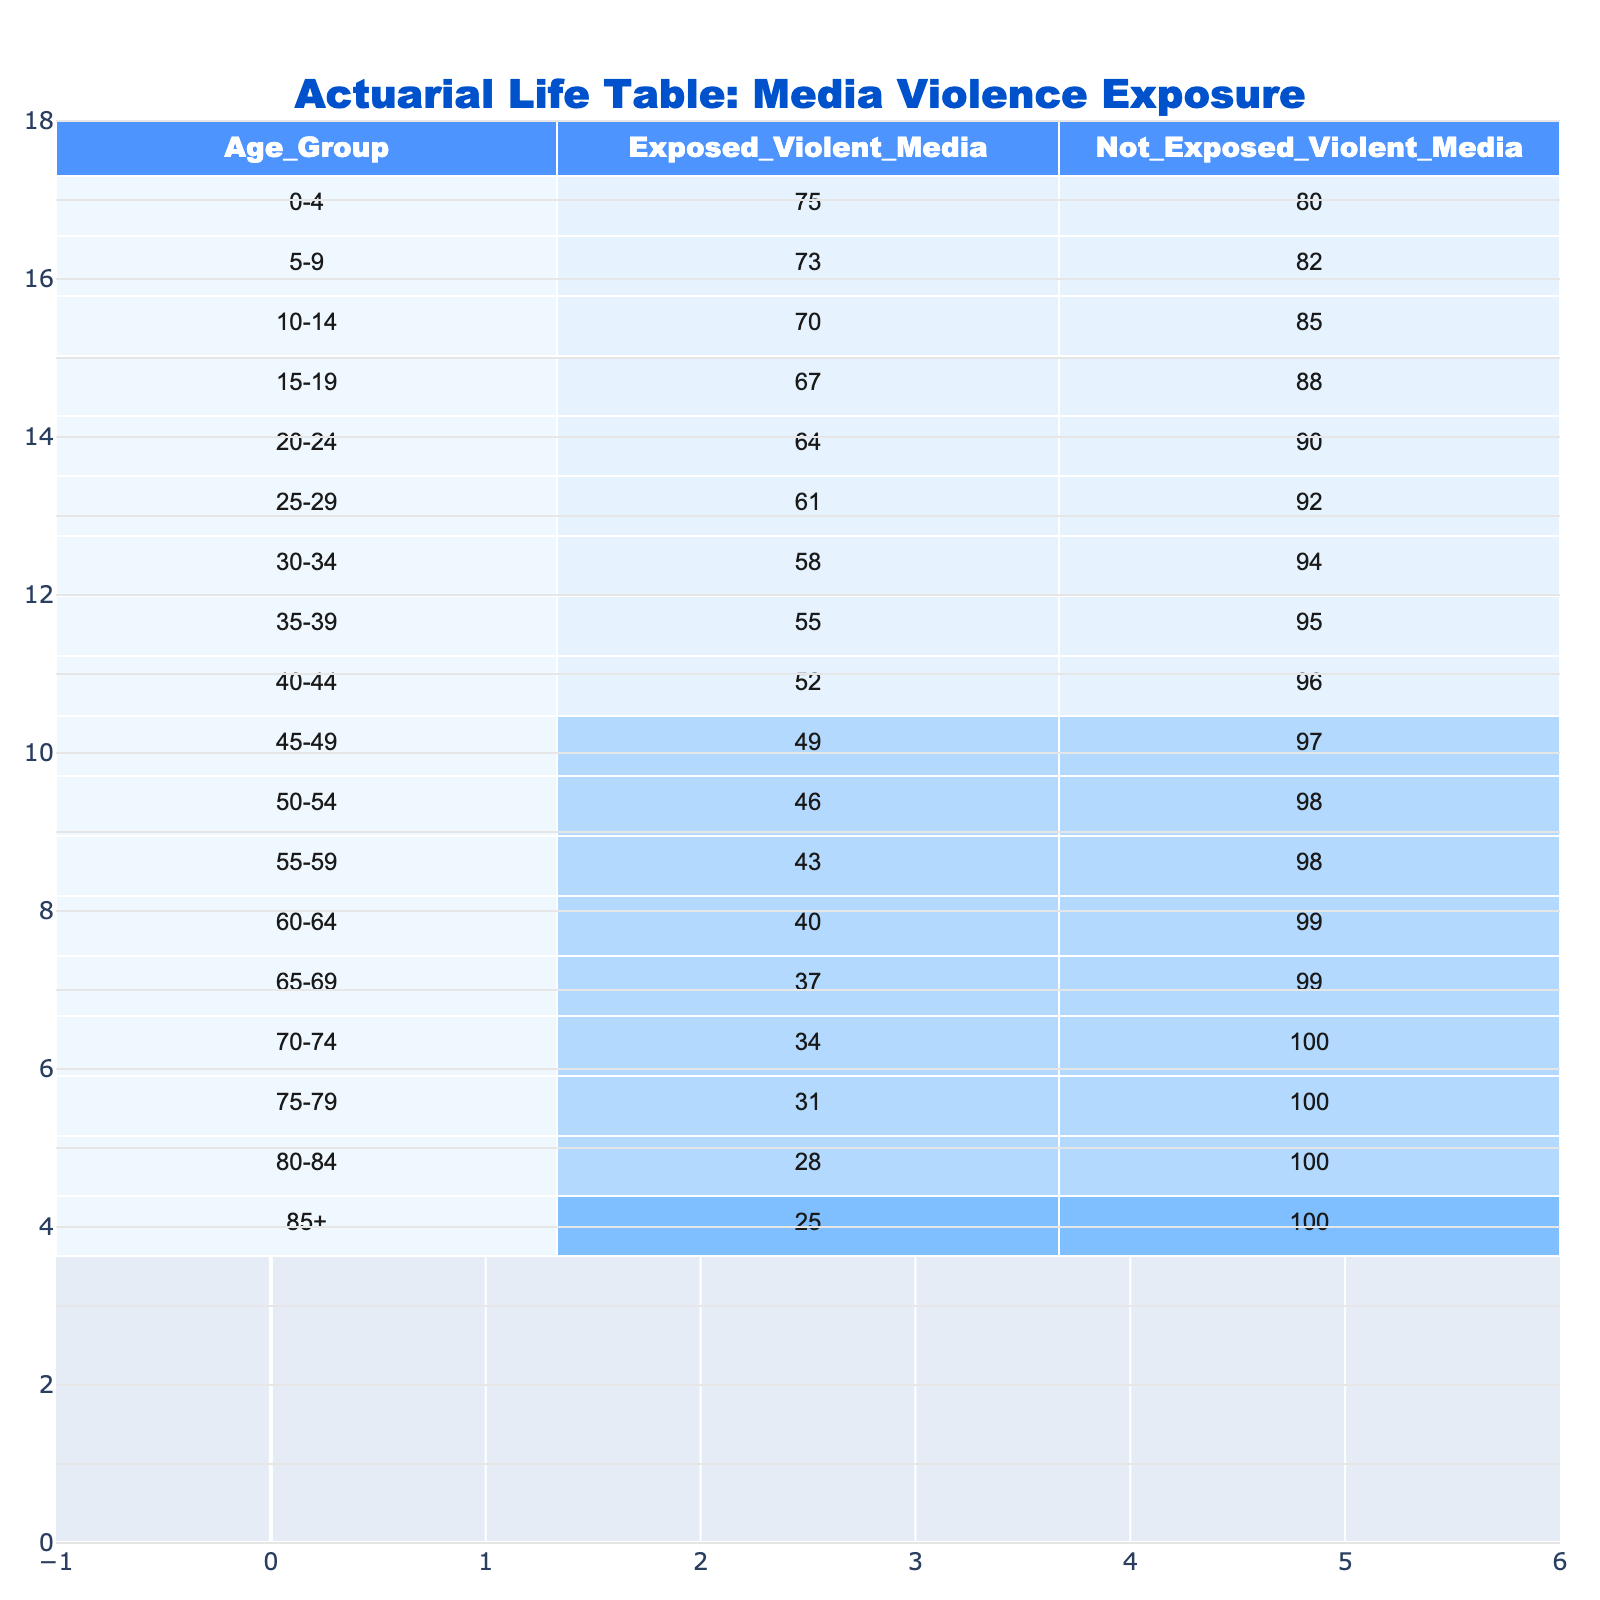What is the life expectancy of children aged 0-4 who are exposed to violent media? According to the table, the life expectancy for the 0-4 age group that is exposed to violent media is 75.
Answer: 75 What is the life expectancy of children aged 5-9 who are not exposed to violent media? The table indicates that the life expectancy for the 5-9 age group that is not exposed to violent media is 82.
Answer: 82 What is the difference in life expectancy between children aged 15-19 who are exposed to violent media and those who are not? The exposed group has a life expectancy of 67, while the not exposed group has a life expectancy of 88. The difference is 88 - 67 = 21.
Answer: 21 What is the average life expectancy of children from ages 10-14 for both exposed and not exposed groups? For the 10-14 age group, the exposed life expectancy is 70, and the not exposed life expectancy is 85. The average is (70 + 85) / 2 = 77.5.
Answer: 77.5 Is the life expectancy for children aged 85+ higher for those exposed to violent media or not exposed? The life expectancy for those exposed to violent media is 25, while for those not exposed, it is 100. Therefore, the life expectancy is higher for not exposed.
Answer: No What age group has the lowest life expectancy for children exposed to violent media? The table shows that the 85+ age group has the lowest life expectancy for children exposed to violent media at 25.
Answer: 85+ At what age does the life expectancy of children exposed to violent media become lower than that of children not exposed? By checking the table, we see that this occurs at age 10-14, where the exposed is 70, and the not exposed is 85.
Answer: At age 10-14 What is the total life expectancy for children aged 30-34 exposed to violent media and those not exposed combined? The life expectancy for exposed children in the 30-34 age group is 58, and for not exposed, it is 94. Total is 58 + 94 = 152.
Answer: 152 Is there a consistent decline in life expectancy for children exposed to violent media as the age group increases? Yes, the table shows a clear trend of declining life expectancy in the exposed group from 75 at 0-4 down to 25 at 85+.
Answer: Yes 